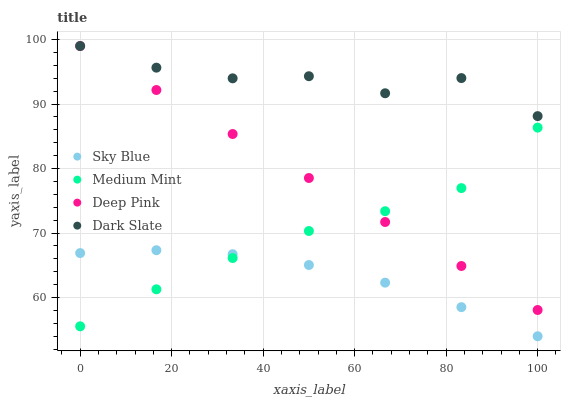Does Sky Blue have the minimum area under the curve?
Answer yes or no. Yes. Does Dark Slate have the maximum area under the curve?
Answer yes or no. Yes. Does Deep Pink have the minimum area under the curve?
Answer yes or no. No. Does Deep Pink have the maximum area under the curve?
Answer yes or no. No. Is Deep Pink the smoothest?
Answer yes or no. Yes. Is Dark Slate the roughest?
Answer yes or no. Yes. Is Sky Blue the smoothest?
Answer yes or no. No. Is Sky Blue the roughest?
Answer yes or no. No. Does Sky Blue have the lowest value?
Answer yes or no. Yes. Does Deep Pink have the lowest value?
Answer yes or no. No. Does Dark Slate have the highest value?
Answer yes or no. Yes. Does Sky Blue have the highest value?
Answer yes or no. No. Is Sky Blue less than Deep Pink?
Answer yes or no. Yes. Is Deep Pink greater than Sky Blue?
Answer yes or no. Yes. Does Deep Pink intersect Medium Mint?
Answer yes or no. Yes. Is Deep Pink less than Medium Mint?
Answer yes or no. No. Is Deep Pink greater than Medium Mint?
Answer yes or no. No. Does Sky Blue intersect Deep Pink?
Answer yes or no. No. 